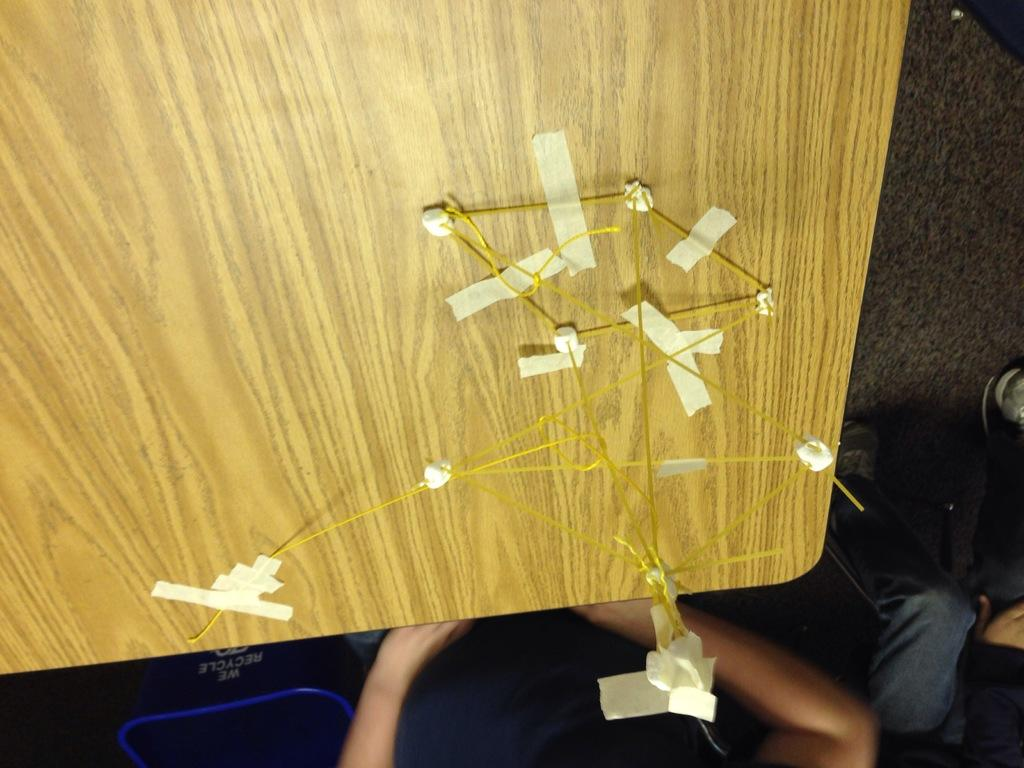What body parts of people can be seen at the bottom of the image? People's hands and legs are visible at the bottom of the image. What piece of furniture is in the center of the image? There is a wooden desk in the center of the image. What items can be seen on the wooden desk? Cables and plasters are present on the wooden desk. What is located on the right side of the image? There is a mat on the right side of the image. What type of railway is visible in the image? There is no railway present in the image. What kind of doctor is attending to the people in the image? There are no doctors or medical situations depicted in the image. 